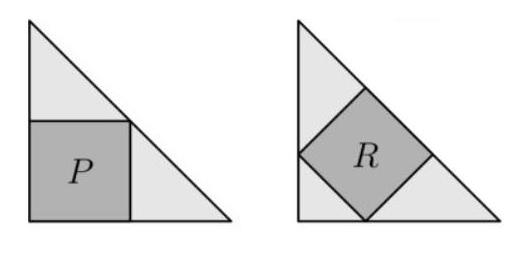Can you explain why squares P and R have different areas even though they are inside congruent triangles? Certainly! While the triangles are congruent and both have a right angle, the squares are positioned differently. Square P's sides are parallel to the triangle's sides, taking up a predictable portion of the triangle. Square R, however, is rotated 45 degrees within the other triangle, with its corners touching the triangle's sides. This orientation means that R occupies more area within its triangle compared to P, as the rotation allows for a larger square to fit. It's a brilliant geometry puzzle that makes us think about how rotation affects area in similar shapes! 